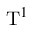<formula> <loc_0><loc_0><loc_500><loc_500>T ^ { 1 }</formula> 